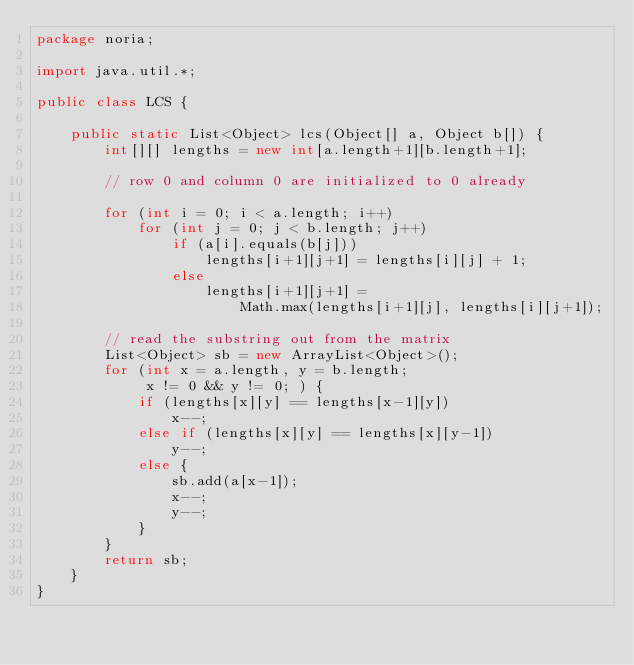Convert code to text. <code><loc_0><loc_0><loc_500><loc_500><_Java_>package noria;

import java.util.*;

public class LCS {

    public static List<Object> lcs(Object[] a, Object b[]) {
        int[][] lengths = new int[a.length+1][b.length+1];
 
        // row 0 and column 0 are initialized to 0 already
 
        for (int i = 0; i < a.length; i++)
            for (int j = 0; j < b.length; j++)
                if (a[i].equals(b[j]))
                    lengths[i+1][j+1] = lengths[i][j] + 1;
                else
                    lengths[i+1][j+1] =
                        Math.max(lengths[i+1][j], lengths[i][j+1]);
 
        // read the substring out from the matrix
        List<Object> sb = new ArrayList<Object>();
        for (int x = a.length, y = b.length;
             x != 0 && y != 0; ) {
            if (lengths[x][y] == lengths[x-1][y])
                x--;
            else if (lengths[x][y] == lengths[x][y-1])
                y--;
            else {
                sb.add(a[x-1]);
                x--;
                y--;
            }
        }
        return sb;
    }
}

</code> 